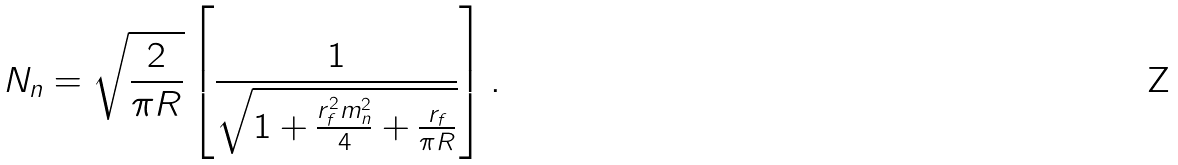<formula> <loc_0><loc_0><loc_500><loc_500>N _ { n } = \sqrt { \frac { 2 } { \pi R } } \left [ \frac { 1 } { \sqrt { 1 + \frac { r _ { f } ^ { 2 } m _ { n } ^ { 2 } } { 4 } + \frac { r _ { f } } { \pi R } } } \right ] .</formula> 